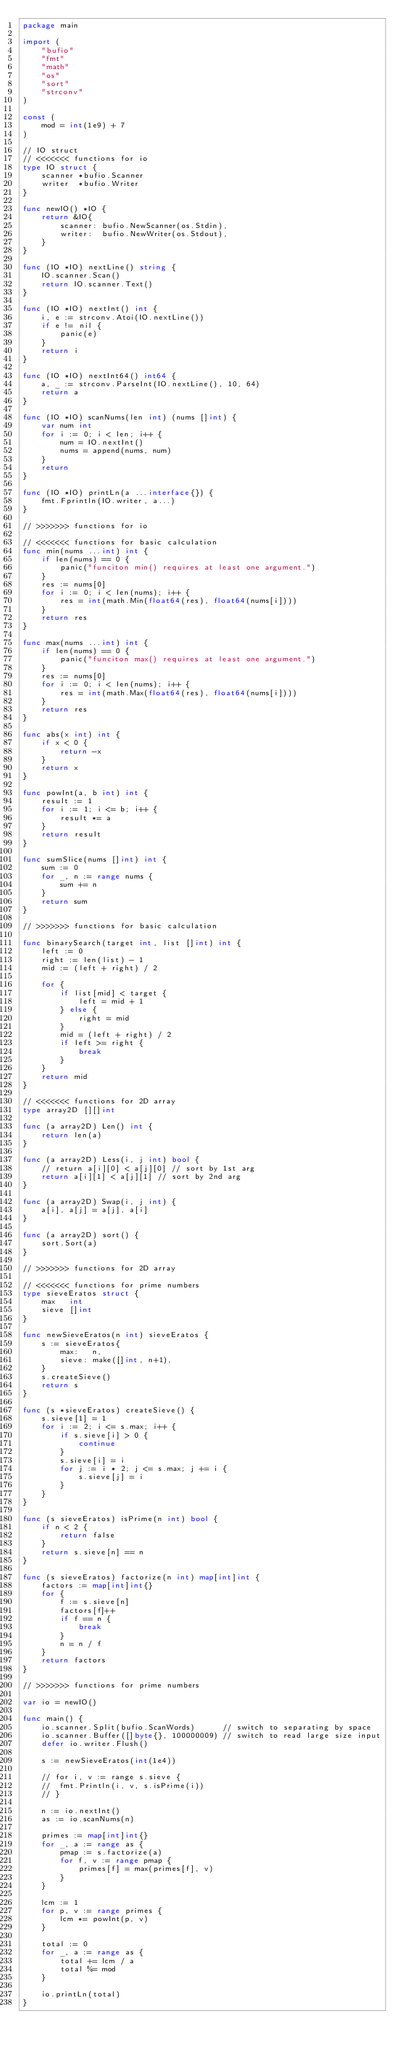<code> <loc_0><loc_0><loc_500><loc_500><_Go_>package main

import (
	"bufio"
	"fmt"
	"math"
	"os"
	"sort"
	"strconv"
)

const (
	mod = int(1e9) + 7
)

// IO struct
// <<<<<<< functions for io
type IO struct {
	scanner *bufio.Scanner
	writer  *bufio.Writer
}

func newIO() *IO {
	return &IO{
		scanner: bufio.NewScanner(os.Stdin),
		writer:  bufio.NewWriter(os.Stdout),
	}
}

func (IO *IO) nextLine() string {
	IO.scanner.Scan()
	return IO.scanner.Text()
}

func (IO *IO) nextInt() int {
	i, e := strconv.Atoi(IO.nextLine())
	if e != nil {
		panic(e)
	}
	return i
}

func (IO *IO) nextInt64() int64 {
	a, _ := strconv.ParseInt(IO.nextLine(), 10, 64)
	return a
}

func (IO *IO) scanNums(len int) (nums []int) {
	var num int
	for i := 0; i < len; i++ {
		num = IO.nextInt()
		nums = append(nums, num)
	}
	return
}

func (IO *IO) printLn(a ...interface{}) {
	fmt.Fprintln(IO.writer, a...)
}

// >>>>>>> functions for io

// <<<<<<< functions for basic calculation
func min(nums ...int) int {
	if len(nums) == 0 {
		panic("funciton min() requires at least one argument.")
	}
	res := nums[0]
	for i := 0; i < len(nums); i++ {
		res = int(math.Min(float64(res), float64(nums[i])))
	}
	return res
}

func max(nums ...int) int {
	if len(nums) == 0 {
		panic("funciton max() requires at least one argument.")
	}
	res := nums[0]
	for i := 0; i < len(nums); i++ {
		res = int(math.Max(float64(res), float64(nums[i])))
	}
	return res
}

func abs(x int) int {
	if x < 0 {
		return -x
	}
	return x
}

func powInt(a, b int) int {
	result := 1
	for i := 1; i <= b; i++ {
		result *= a
	}
	return result
}

func sumSlice(nums []int) int {
	sum := 0
	for _, n := range nums {
		sum += n
	}
	return sum
}

// >>>>>>> functions for basic calculation

func binarySearch(target int, list []int) int {
	left := 0
	right := len(list) - 1
	mid := (left + right) / 2

	for {
		if list[mid] < target {
			left = mid + 1
		} else {
			right = mid
		}
		mid = (left + right) / 2
		if left >= right {
			break
		}
	}
	return mid
}

// <<<<<<< functions for 2D array
type array2D [][]int

func (a array2D) Len() int {
	return len(a)
}

func (a array2D) Less(i, j int) bool {
	// return a[i][0] < a[j][0] // sort by 1st arg
	return a[i][1] < a[j][1] // sort by 2nd arg
}

func (a array2D) Swap(i, j int) {
	a[i], a[j] = a[j], a[i]
}

func (a array2D) sort() {
	sort.Sort(a)
}

// >>>>>>> functions for 2D array

// <<<<<<< functions for prime numbers
type sieveEratos struct {
	max   int
	sieve []int
}

func newSieveEratos(n int) sieveEratos {
	s := sieveEratos{
		max:   n,
		sieve: make([]int, n+1),
	}
	s.createSieve()
	return s
}

func (s *sieveEratos) createSieve() {
	s.sieve[1] = 1
	for i := 2; i <= s.max; i++ {
		if s.sieve[i] > 0 {
			continue
		}
		s.sieve[i] = i
		for j := i * 2; j <= s.max; j += i {
			s.sieve[j] = i
		}
	}
}

func (s sieveEratos) isPrime(n int) bool {
	if n < 2 {
		return false
	}
	return s.sieve[n] == n
}

func (s sieveEratos) factorize(n int) map[int]int {
	factors := map[int]int{}
	for {
		f := s.sieve[n]
		factors[f]++
		if f == n {
			break
		}
		n = n / f
	}
	return factors
}

// >>>>>>> functions for prime numbers

var io = newIO()

func main() {
	io.scanner.Split(bufio.ScanWords)      // switch to separating by space
	io.scanner.Buffer([]byte{}, 100000009) // switch to read large size input
	defer io.writer.Flush()

	s := newSieveEratos(int(1e4))

	// for i, v := range s.sieve {
	// 	fmt.Println(i, v, s.isPrime(i))
	// }

	n := io.nextInt()
	as := io.scanNums(n)

	primes := map[int]int{}
	for _, a := range as {
		pmap := s.factorize(a)
		for f, v := range pmap {
			primes[f] = max(primes[f], v)
		}
	}

	lcm := 1
	for p, v := range primes {
		lcm *= powInt(p, v)
	}

	total := 0
	for _, a := range as {
		total += lcm / a
		total %= mod
	}

	io.printLn(total)
}
</code> 